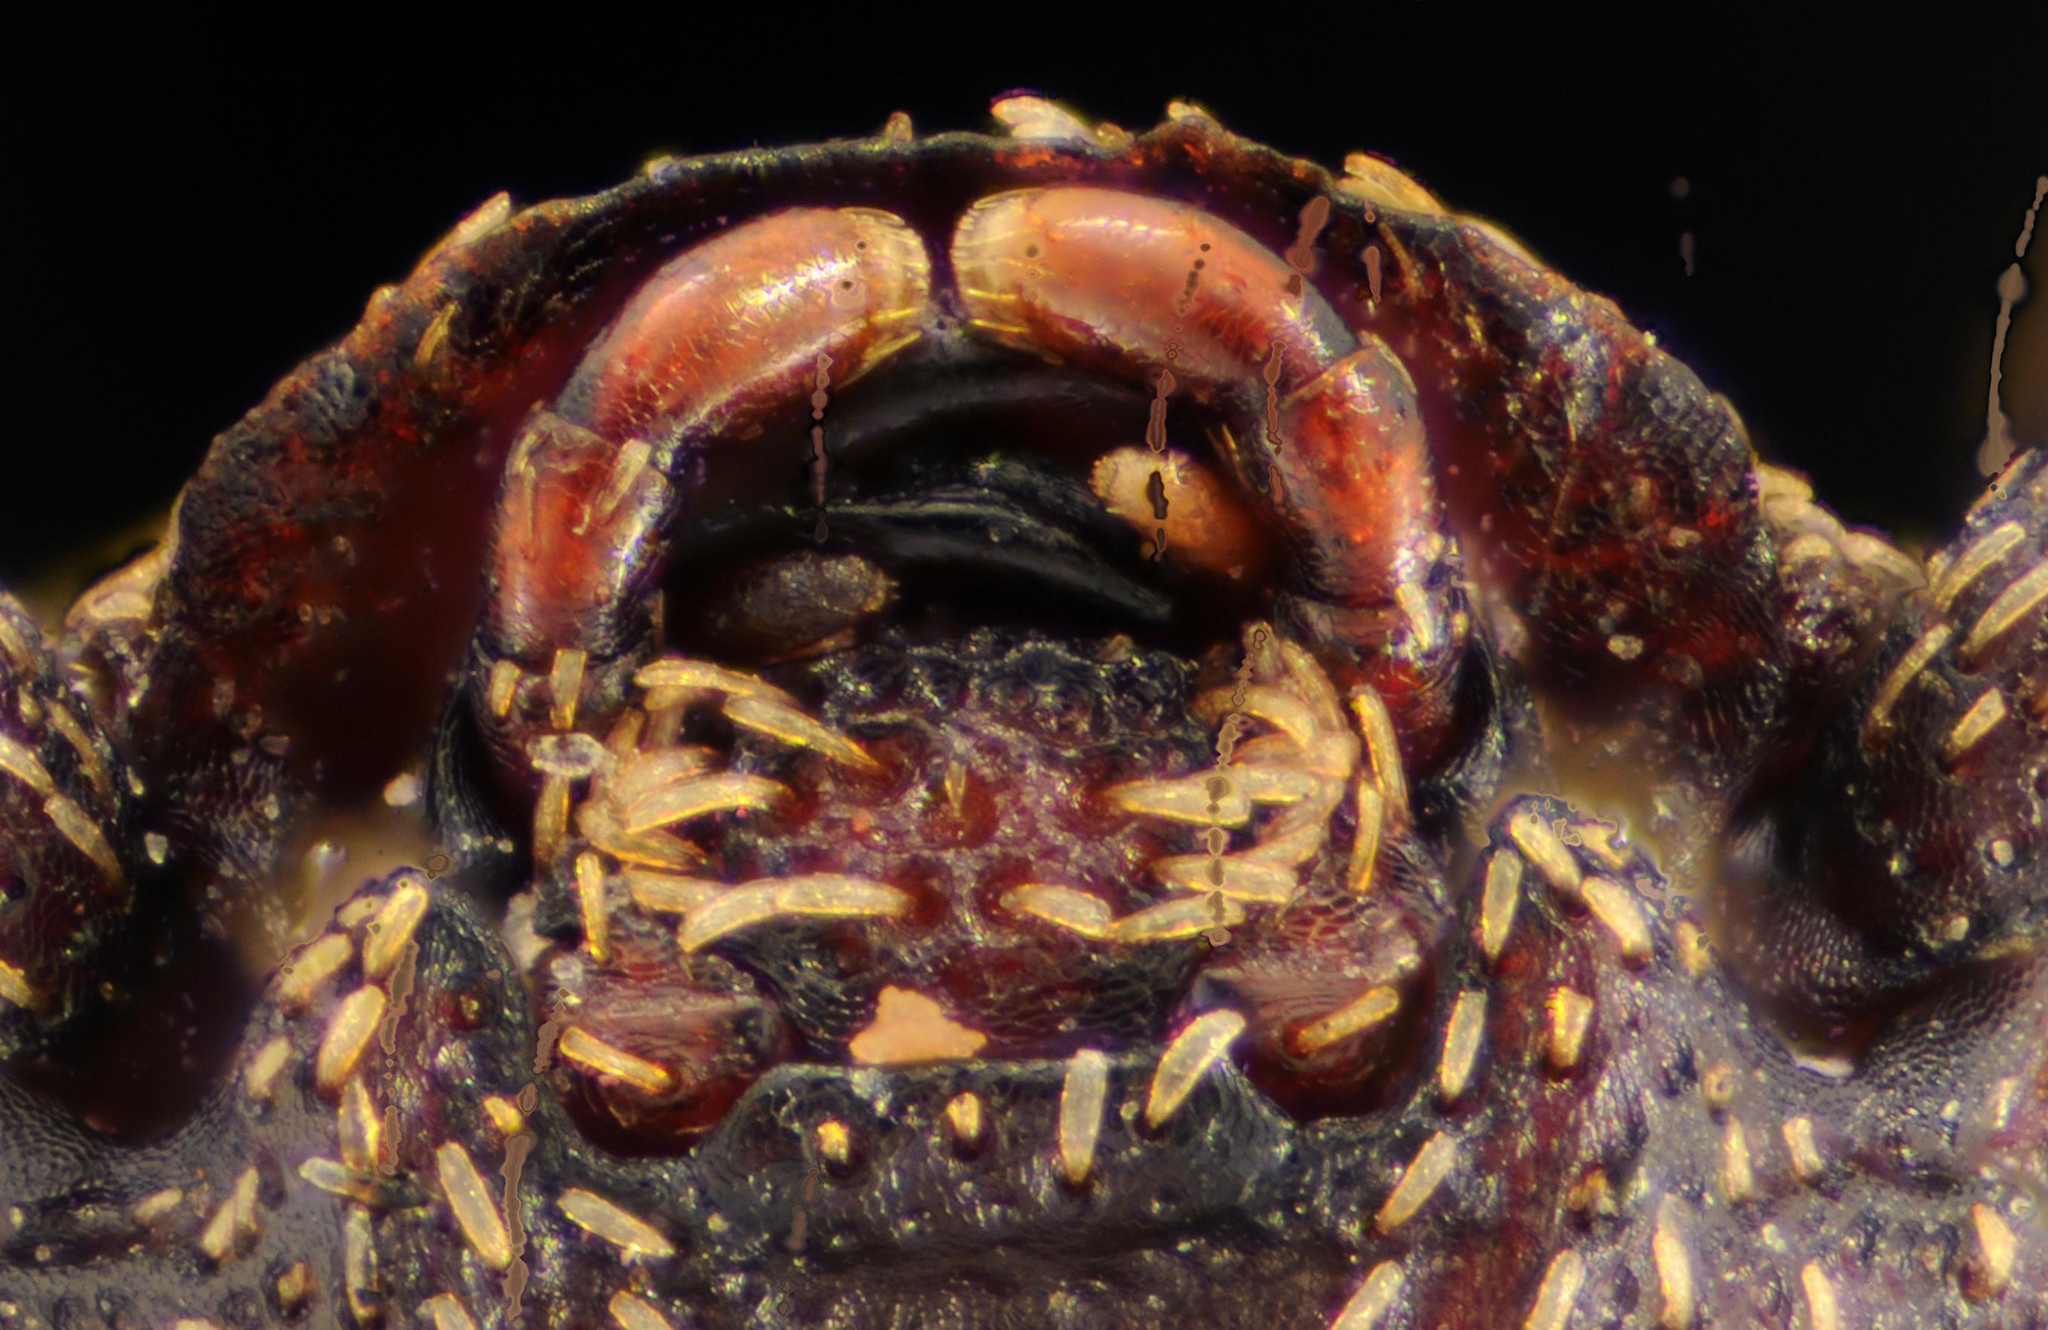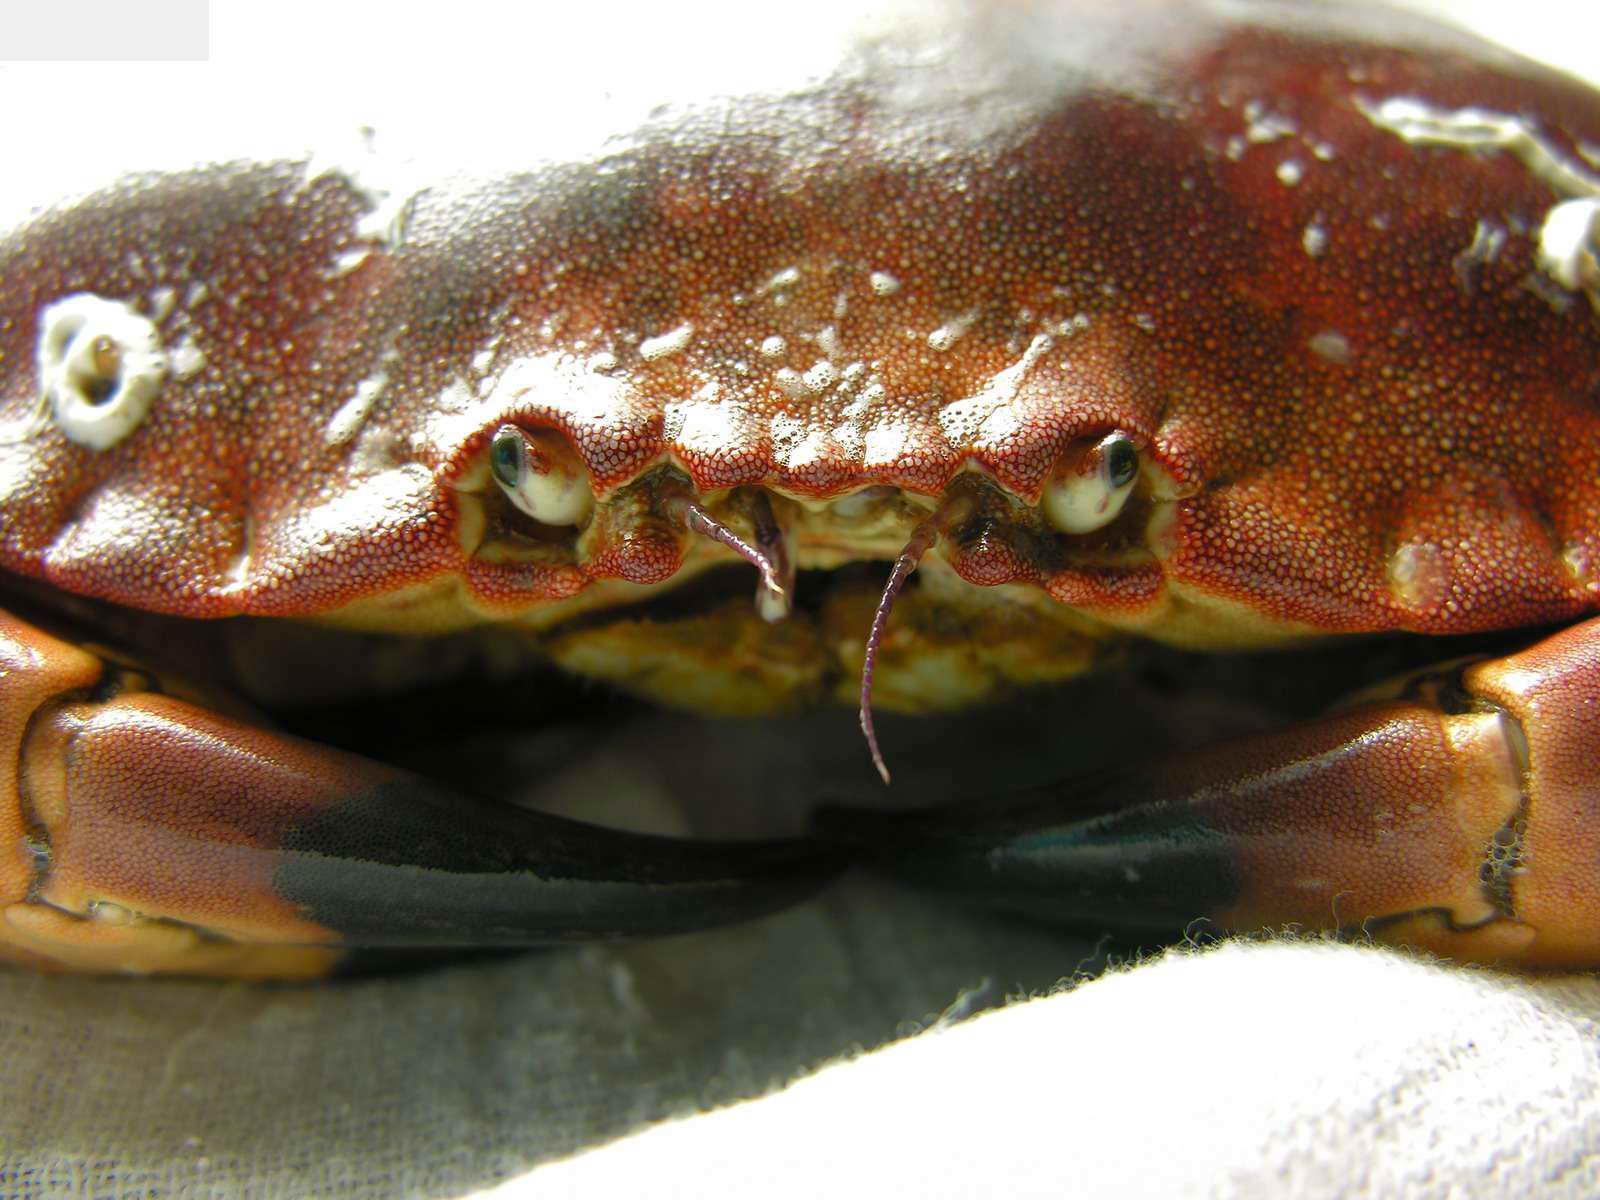The first image is the image on the left, the second image is the image on the right. Considering the images on both sides, is "In at least one image you can see a single crab top shell, two eye and a slightly opened mouth." valid? Answer yes or no. Yes. 